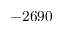Convert formula to latex. <formula><loc_0><loc_0><loc_500><loc_500>- 2 6 9 0</formula> 